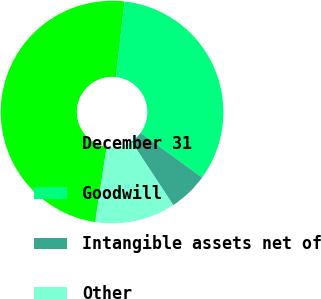Convert chart. <chart><loc_0><loc_0><loc_500><loc_500><pie_chart><fcel>December 31<fcel>Goodwill<fcel>Intangible assets net of<fcel>Other<nl><fcel>49.36%<fcel>33.21%<fcel>5.74%<fcel>11.69%<nl></chart> 